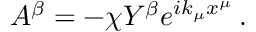Convert formula to latex. <formula><loc_0><loc_0><loc_500><loc_500>A ^ { \beta } = - \chi Y ^ { \beta } e ^ { i k _ { \mu } x ^ { \mu } } \, .</formula> 